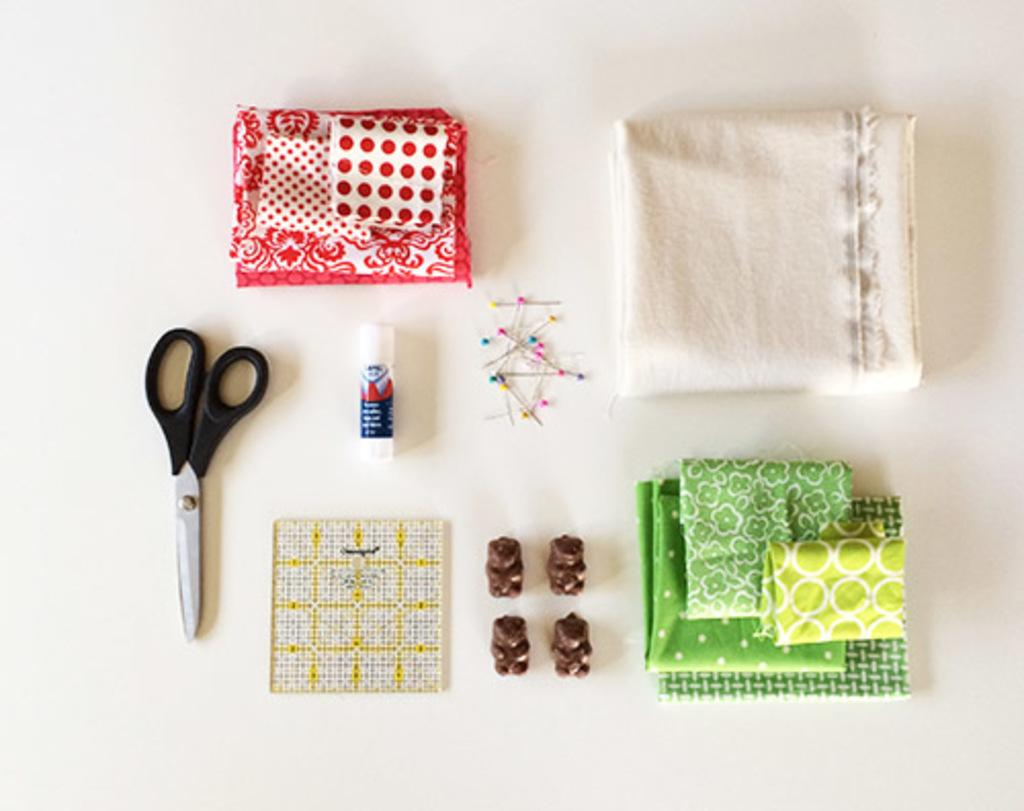What items can be seen in the image related to clothing or sewing? There are clothes, sewing pins, and scissors in the image. Can you describe any other objects present in the image? There are some unspecified objects in the image. How many men are visible in the image? There is no mention of men in the image; it features clothes, sewing pins, scissors, and unspecified objects. Is there a crib present in the image? There is no crib present in the image. 